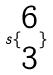Convert formula to latex. <formula><loc_0><loc_0><loc_500><loc_500>s \{ \begin{matrix} 6 \\ 3 \end{matrix} \}</formula> 